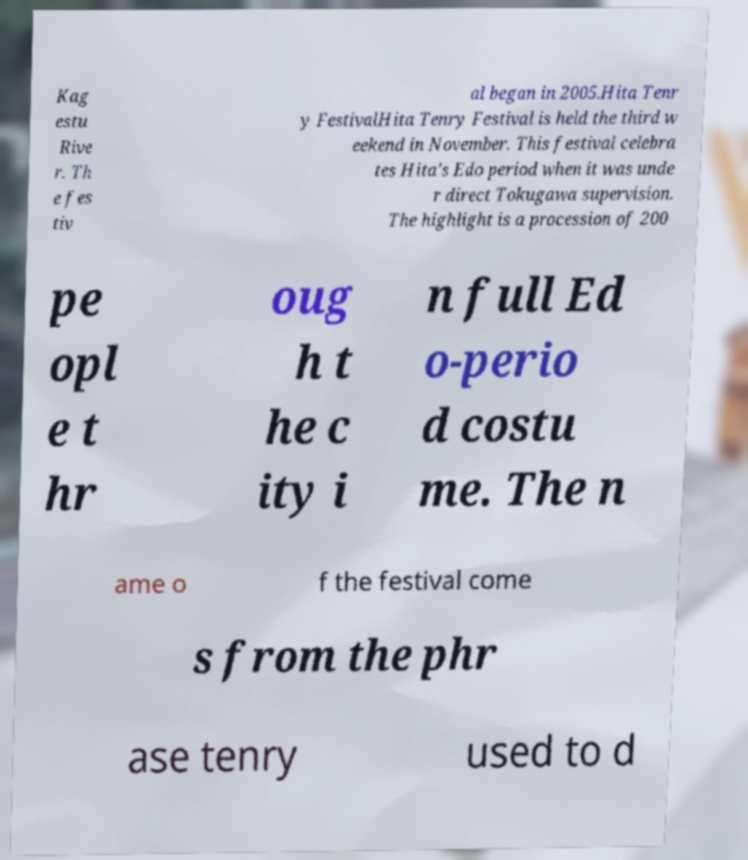There's text embedded in this image that I need extracted. Can you transcribe it verbatim? Kag estu Rive r. Th e fes tiv al began in 2005.Hita Tenr y FestivalHita Tenry Festival is held the third w eekend in November. This festival celebra tes Hita's Edo period when it was unde r direct Tokugawa supervision. The highlight is a procession of 200 pe opl e t hr oug h t he c ity i n full Ed o-perio d costu me. The n ame o f the festival come s from the phr ase tenry used to d 